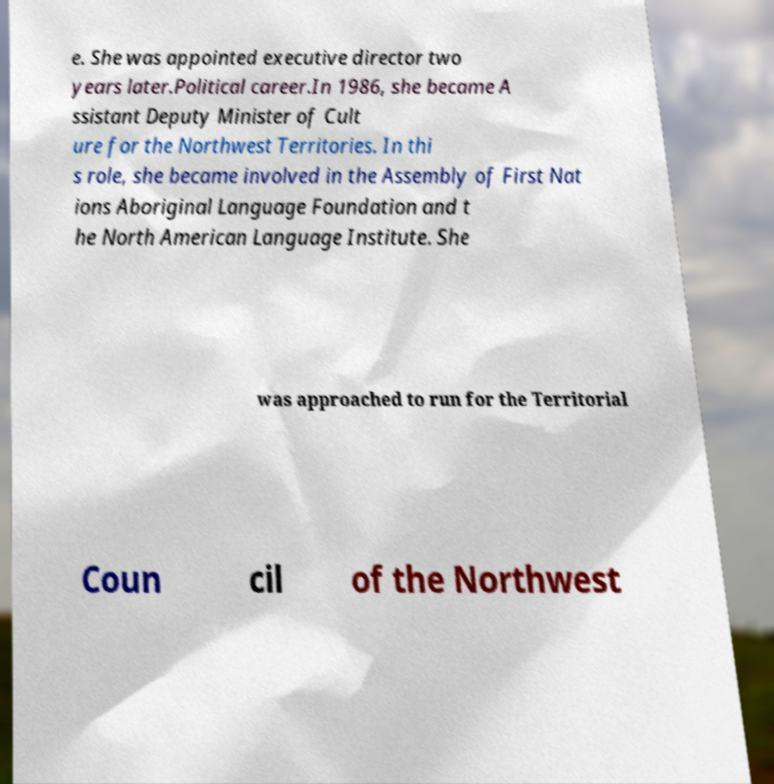Could you assist in decoding the text presented in this image and type it out clearly? e. She was appointed executive director two years later.Political career.In 1986, she became A ssistant Deputy Minister of Cult ure for the Northwest Territories. In thi s role, she became involved in the Assembly of First Nat ions Aboriginal Language Foundation and t he North American Language Institute. She was approached to run for the Territorial Coun cil of the Northwest 